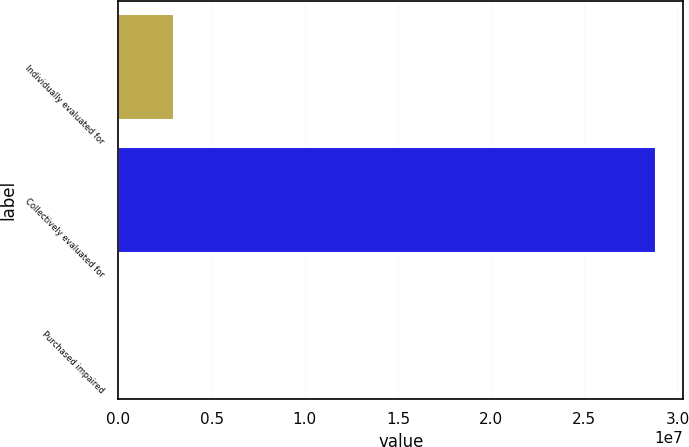Convert chart. <chart><loc_0><loc_0><loc_500><loc_500><bar_chart><fcel>Individually evaluated for<fcel>Collectively evaluated for<fcel>Purchased impaired<nl><fcel>2.97636e+06<fcel>2.88631e+07<fcel>100049<nl></chart> 